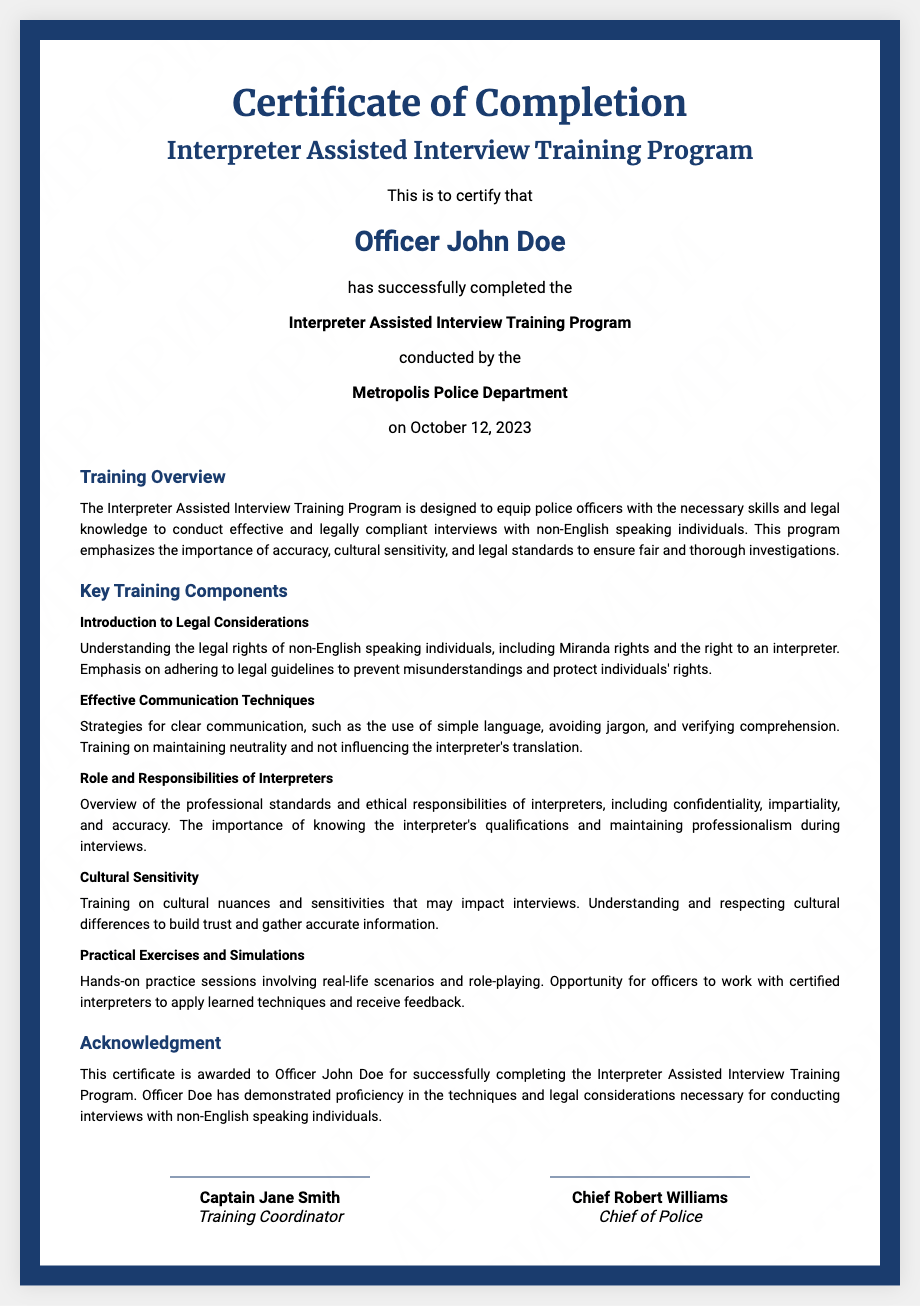What is the name of the program completed? The program completed is clearly stated in the title of the certificate, which is "Interpreter Assisted Interview Training Program."
Answer: Interpreter Assisted Interview Training Program Who issued the certificate? The issuing authority is mentioned in the document as the "Metropolis Police Department."
Answer: Metropolis Police Department What is the name of the officer who completed the training? The name of the officer is highlighted in the holder section of the document, which states "Officer John Doe."
Answer: Officer John Doe On what date was the training completed? The completion date is specified in the details section, stating "on October 12, 2023."
Answer: October 12, 2023 What is one of the key training components mentioned? The document lists various components, one of which is "Introduction to Legal Considerations."
Answer: Introduction to Legal Considerations What should police officers maintain during interviews? The document emphasizes the need for police officers to maintain "neutrality" during interviews.
Answer: Neutrality Who is the Training Coordinator? The signature section identifies the Training Coordinator as "Captain Jane Smith."
Answer: Captain Jane Smith What is emphasized as important in interviewing non-English speaking individuals? The document mentions the importance of "cultural sensitivity" in conducting interviews.
Answer: Cultural sensitivity How many signatures are on the certificate? The signature section of the document shows that there are two signatures.
Answer: Two 